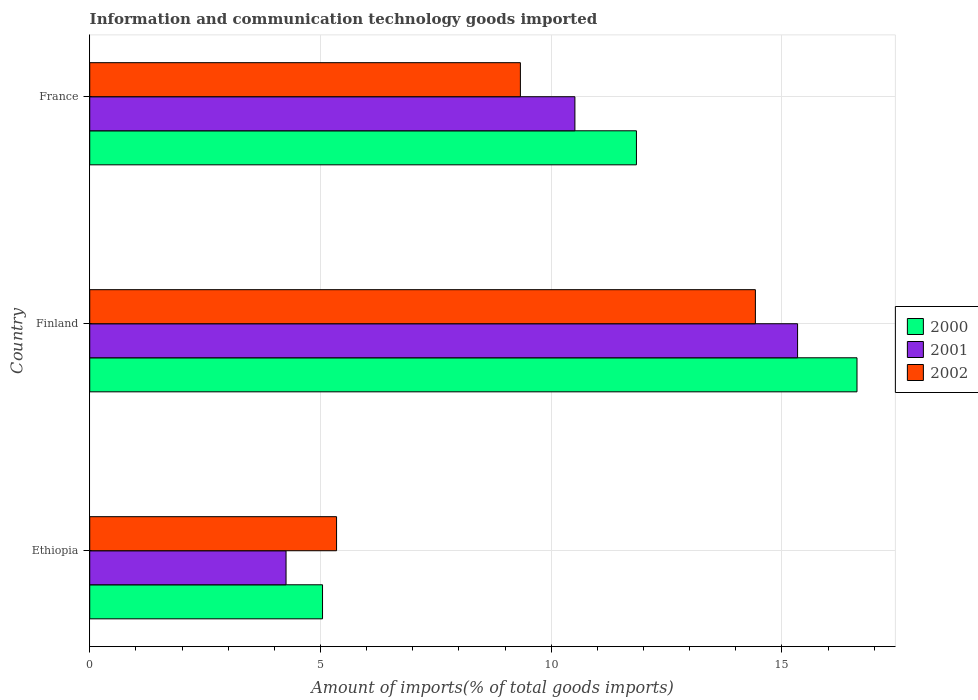How many different coloured bars are there?
Keep it short and to the point. 3. How many groups of bars are there?
Offer a very short reply. 3. How many bars are there on the 3rd tick from the top?
Ensure brevity in your answer.  3. What is the label of the 1st group of bars from the top?
Offer a very short reply. France. What is the amount of goods imported in 2000 in France?
Your response must be concise. 11.85. Across all countries, what is the maximum amount of goods imported in 2001?
Offer a terse response. 15.34. Across all countries, what is the minimum amount of goods imported in 2001?
Provide a succinct answer. 4.25. In which country was the amount of goods imported in 2000 minimum?
Offer a terse response. Ethiopia. What is the total amount of goods imported in 2000 in the graph?
Your response must be concise. 33.52. What is the difference between the amount of goods imported in 2002 in Finland and that in France?
Your response must be concise. 5.09. What is the difference between the amount of goods imported in 2000 in Ethiopia and the amount of goods imported in 2002 in Finland?
Keep it short and to the point. -9.38. What is the average amount of goods imported in 2002 per country?
Provide a short and direct response. 9.7. What is the difference between the amount of goods imported in 2001 and amount of goods imported in 2000 in Ethiopia?
Offer a terse response. -0.79. What is the ratio of the amount of goods imported in 2002 in Ethiopia to that in France?
Your answer should be compact. 0.57. Is the amount of goods imported in 2001 in Ethiopia less than that in France?
Your answer should be compact. Yes. Is the difference between the amount of goods imported in 2001 in Ethiopia and France greater than the difference between the amount of goods imported in 2000 in Ethiopia and France?
Your answer should be very brief. Yes. What is the difference between the highest and the second highest amount of goods imported in 2001?
Keep it short and to the point. 4.83. What is the difference between the highest and the lowest amount of goods imported in 2000?
Offer a very short reply. 11.58. In how many countries, is the amount of goods imported in 2002 greater than the average amount of goods imported in 2002 taken over all countries?
Keep it short and to the point. 1. Is the sum of the amount of goods imported in 2000 in Finland and France greater than the maximum amount of goods imported in 2002 across all countries?
Provide a short and direct response. Yes. What does the 2nd bar from the bottom in Ethiopia represents?
Your answer should be very brief. 2001. How many countries are there in the graph?
Your answer should be very brief. 3. What is the difference between two consecutive major ticks on the X-axis?
Give a very brief answer. 5. Are the values on the major ticks of X-axis written in scientific E-notation?
Ensure brevity in your answer.  No. Does the graph contain grids?
Provide a short and direct response. Yes. Where does the legend appear in the graph?
Ensure brevity in your answer.  Center right. What is the title of the graph?
Provide a succinct answer. Information and communication technology goods imported. What is the label or title of the X-axis?
Your answer should be compact. Amount of imports(% of total goods imports). What is the label or title of the Y-axis?
Provide a succinct answer. Country. What is the Amount of imports(% of total goods imports) of 2000 in Ethiopia?
Provide a succinct answer. 5.05. What is the Amount of imports(% of total goods imports) of 2001 in Ethiopia?
Keep it short and to the point. 4.25. What is the Amount of imports(% of total goods imports) in 2002 in Ethiopia?
Make the answer very short. 5.35. What is the Amount of imports(% of total goods imports) of 2000 in Finland?
Your answer should be very brief. 16.63. What is the Amount of imports(% of total goods imports) of 2001 in Finland?
Make the answer very short. 15.34. What is the Amount of imports(% of total goods imports) of 2002 in Finland?
Offer a very short reply. 14.43. What is the Amount of imports(% of total goods imports) in 2000 in France?
Your response must be concise. 11.85. What is the Amount of imports(% of total goods imports) in 2001 in France?
Provide a short and direct response. 10.51. What is the Amount of imports(% of total goods imports) of 2002 in France?
Provide a succinct answer. 9.33. Across all countries, what is the maximum Amount of imports(% of total goods imports) of 2000?
Keep it short and to the point. 16.63. Across all countries, what is the maximum Amount of imports(% of total goods imports) of 2001?
Your response must be concise. 15.34. Across all countries, what is the maximum Amount of imports(% of total goods imports) of 2002?
Your answer should be very brief. 14.43. Across all countries, what is the minimum Amount of imports(% of total goods imports) in 2000?
Your answer should be very brief. 5.05. Across all countries, what is the minimum Amount of imports(% of total goods imports) in 2001?
Your response must be concise. 4.25. Across all countries, what is the minimum Amount of imports(% of total goods imports) of 2002?
Offer a very short reply. 5.35. What is the total Amount of imports(% of total goods imports) of 2000 in the graph?
Offer a terse response. 33.52. What is the total Amount of imports(% of total goods imports) in 2001 in the graph?
Provide a succinct answer. 30.11. What is the total Amount of imports(% of total goods imports) in 2002 in the graph?
Your answer should be compact. 29.11. What is the difference between the Amount of imports(% of total goods imports) of 2000 in Ethiopia and that in Finland?
Your answer should be very brief. -11.58. What is the difference between the Amount of imports(% of total goods imports) of 2001 in Ethiopia and that in Finland?
Ensure brevity in your answer.  -11.09. What is the difference between the Amount of imports(% of total goods imports) of 2002 in Ethiopia and that in Finland?
Keep it short and to the point. -9.08. What is the difference between the Amount of imports(% of total goods imports) in 2000 in Ethiopia and that in France?
Keep it short and to the point. -6.8. What is the difference between the Amount of imports(% of total goods imports) in 2001 in Ethiopia and that in France?
Make the answer very short. -6.26. What is the difference between the Amount of imports(% of total goods imports) in 2002 in Ethiopia and that in France?
Offer a very short reply. -3.98. What is the difference between the Amount of imports(% of total goods imports) of 2000 in Finland and that in France?
Give a very brief answer. 4.78. What is the difference between the Amount of imports(% of total goods imports) in 2001 in Finland and that in France?
Offer a very short reply. 4.83. What is the difference between the Amount of imports(% of total goods imports) in 2002 in Finland and that in France?
Give a very brief answer. 5.09. What is the difference between the Amount of imports(% of total goods imports) in 2000 in Ethiopia and the Amount of imports(% of total goods imports) in 2001 in Finland?
Your response must be concise. -10.29. What is the difference between the Amount of imports(% of total goods imports) of 2000 in Ethiopia and the Amount of imports(% of total goods imports) of 2002 in Finland?
Ensure brevity in your answer.  -9.38. What is the difference between the Amount of imports(% of total goods imports) in 2001 in Ethiopia and the Amount of imports(% of total goods imports) in 2002 in Finland?
Give a very brief answer. -10.17. What is the difference between the Amount of imports(% of total goods imports) in 2000 in Ethiopia and the Amount of imports(% of total goods imports) in 2001 in France?
Make the answer very short. -5.47. What is the difference between the Amount of imports(% of total goods imports) of 2000 in Ethiopia and the Amount of imports(% of total goods imports) of 2002 in France?
Give a very brief answer. -4.29. What is the difference between the Amount of imports(% of total goods imports) in 2001 in Ethiopia and the Amount of imports(% of total goods imports) in 2002 in France?
Ensure brevity in your answer.  -5.08. What is the difference between the Amount of imports(% of total goods imports) in 2000 in Finland and the Amount of imports(% of total goods imports) in 2001 in France?
Your answer should be compact. 6.11. What is the difference between the Amount of imports(% of total goods imports) in 2000 in Finland and the Amount of imports(% of total goods imports) in 2002 in France?
Your answer should be very brief. 7.29. What is the difference between the Amount of imports(% of total goods imports) in 2001 in Finland and the Amount of imports(% of total goods imports) in 2002 in France?
Make the answer very short. 6.01. What is the average Amount of imports(% of total goods imports) of 2000 per country?
Your answer should be very brief. 11.17. What is the average Amount of imports(% of total goods imports) in 2001 per country?
Provide a succinct answer. 10.04. What is the average Amount of imports(% of total goods imports) in 2002 per country?
Offer a very short reply. 9.7. What is the difference between the Amount of imports(% of total goods imports) of 2000 and Amount of imports(% of total goods imports) of 2001 in Ethiopia?
Your response must be concise. 0.79. What is the difference between the Amount of imports(% of total goods imports) of 2000 and Amount of imports(% of total goods imports) of 2002 in Ethiopia?
Provide a succinct answer. -0.3. What is the difference between the Amount of imports(% of total goods imports) of 2001 and Amount of imports(% of total goods imports) of 2002 in Ethiopia?
Provide a short and direct response. -1.09. What is the difference between the Amount of imports(% of total goods imports) in 2000 and Amount of imports(% of total goods imports) in 2001 in Finland?
Offer a terse response. 1.29. What is the difference between the Amount of imports(% of total goods imports) of 2000 and Amount of imports(% of total goods imports) of 2002 in Finland?
Keep it short and to the point. 2.2. What is the difference between the Amount of imports(% of total goods imports) of 2001 and Amount of imports(% of total goods imports) of 2002 in Finland?
Offer a very short reply. 0.91. What is the difference between the Amount of imports(% of total goods imports) of 2000 and Amount of imports(% of total goods imports) of 2001 in France?
Provide a short and direct response. 1.33. What is the difference between the Amount of imports(% of total goods imports) of 2000 and Amount of imports(% of total goods imports) of 2002 in France?
Ensure brevity in your answer.  2.51. What is the difference between the Amount of imports(% of total goods imports) in 2001 and Amount of imports(% of total goods imports) in 2002 in France?
Provide a succinct answer. 1.18. What is the ratio of the Amount of imports(% of total goods imports) of 2000 in Ethiopia to that in Finland?
Provide a short and direct response. 0.3. What is the ratio of the Amount of imports(% of total goods imports) in 2001 in Ethiopia to that in Finland?
Provide a short and direct response. 0.28. What is the ratio of the Amount of imports(% of total goods imports) in 2002 in Ethiopia to that in Finland?
Your answer should be very brief. 0.37. What is the ratio of the Amount of imports(% of total goods imports) in 2000 in Ethiopia to that in France?
Give a very brief answer. 0.43. What is the ratio of the Amount of imports(% of total goods imports) in 2001 in Ethiopia to that in France?
Give a very brief answer. 0.4. What is the ratio of the Amount of imports(% of total goods imports) of 2002 in Ethiopia to that in France?
Your response must be concise. 0.57. What is the ratio of the Amount of imports(% of total goods imports) in 2000 in Finland to that in France?
Ensure brevity in your answer.  1.4. What is the ratio of the Amount of imports(% of total goods imports) in 2001 in Finland to that in France?
Offer a very short reply. 1.46. What is the ratio of the Amount of imports(% of total goods imports) of 2002 in Finland to that in France?
Your response must be concise. 1.55. What is the difference between the highest and the second highest Amount of imports(% of total goods imports) of 2000?
Give a very brief answer. 4.78. What is the difference between the highest and the second highest Amount of imports(% of total goods imports) of 2001?
Keep it short and to the point. 4.83. What is the difference between the highest and the second highest Amount of imports(% of total goods imports) of 2002?
Offer a terse response. 5.09. What is the difference between the highest and the lowest Amount of imports(% of total goods imports) of 2000?
Ensure brevity in your answer.  11.58. What is the difference between the highest and the lowest Amount of imports(% of total goods imports) of 2001?
Your answer should be very brief. 11.09. What is the difference between the highest and the lowest Amount of imports(% of total goods imports) in 2002?
Offer a very short reply. 9.08. 